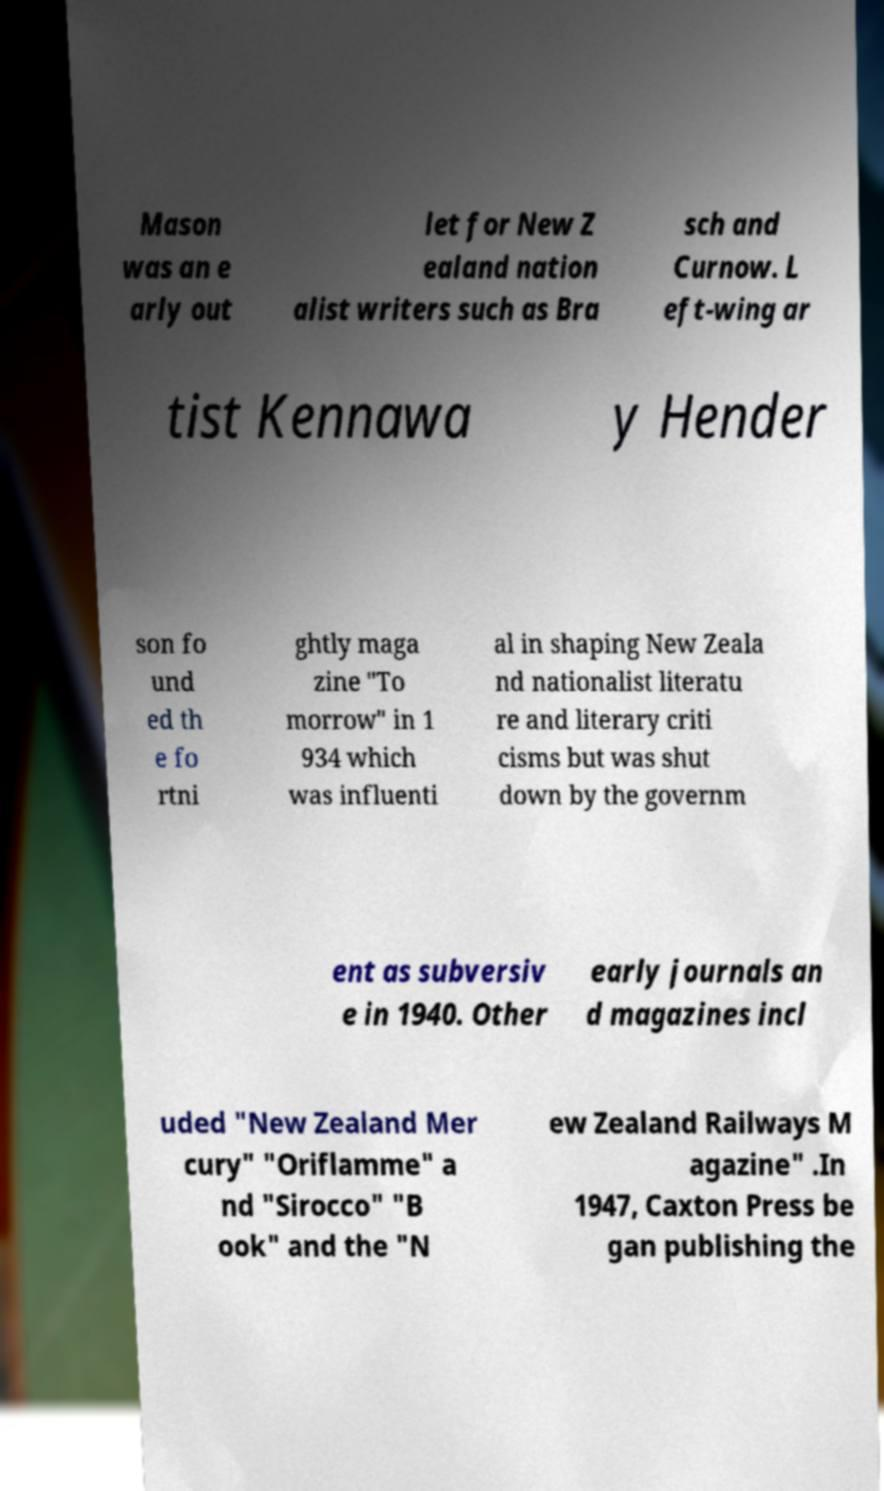Please identify and transcribe the text found in this image. Mason was an e arly out let for New Z ealand nation alist writers such as Bra sch and Curnow. L eft-wing ar tist Kennawa y Hender son fo und ed th e fo rtni ghtly maga zine "To morrow" in 1 934 which was influenti al in shaping New Zeala nd nationalist literatu re and literary criti cisms but was shut down by the governm ent as subversiv e in 1940. Other early journals an d magazines incl uded "New Zealand Mer cury" "Oriflamme" a nd "Sirocco" "B ook" and the "N ew Zealand Railways M agazine" .In 1947, Caxton Press be gan publishing the 